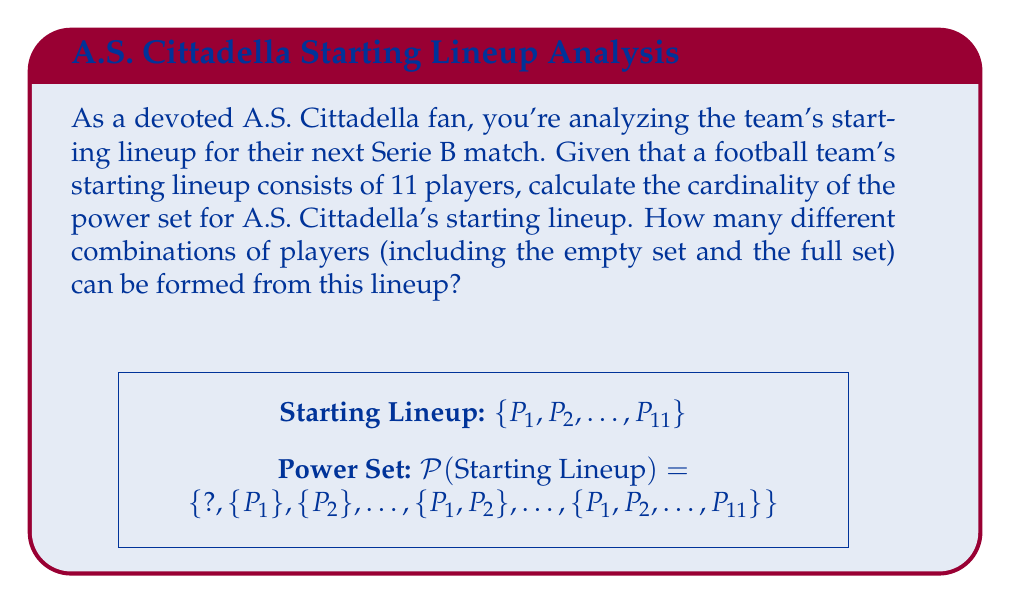What is the answer to this math problem? Let's approach this step-by-step:

1) First, recall that the power set of a set $A$ is the set of all subsets of $A$, including the empty set and $A$ itself.

2) For a set with $n$ elements, the cardinality of its power set is $2^n$.

3) In this case, A.S. Cittadella's starting lineup consists of 11 players. So, $n = 11$.

4) Therefore, we need to calculate $2^{11}$.

5) We can compute this:

   $$2^{11} = 2 \times 2 \times 2 \times 2 \times 2 \times 2 \times 2 \times 2 \times 2 \times 2 \times 2 = 2048$$

6) This means there are 2048 different possible subsets (combinations of players) that can be formed from the starting lineup, including:
   - The empty set (no players selected)
   - 11 subsets with just one player
   - Subsets with 2, 3, 4, ..., 10 players
   - The full set (all 11 players)

Thus, the cardinality of the power set of A.S. Cittadella's starting lineup is 2048.
Answer: $2^{11} = 2048$ 